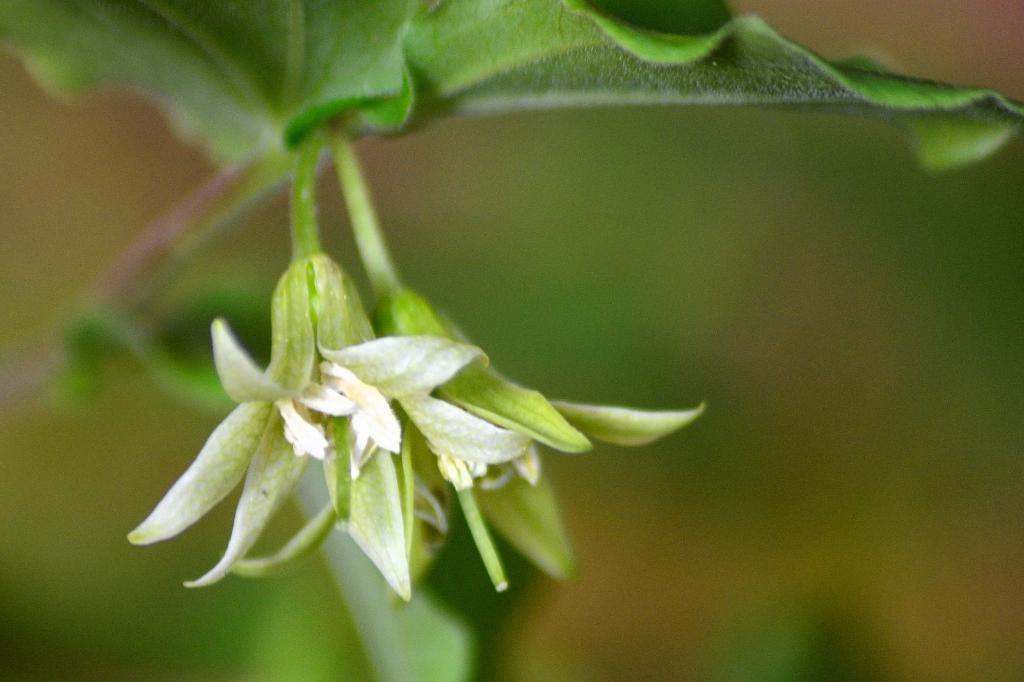How would you summarize this image in a sentence or two? In the picture I can see flower plant. The background of the image is blurred. 